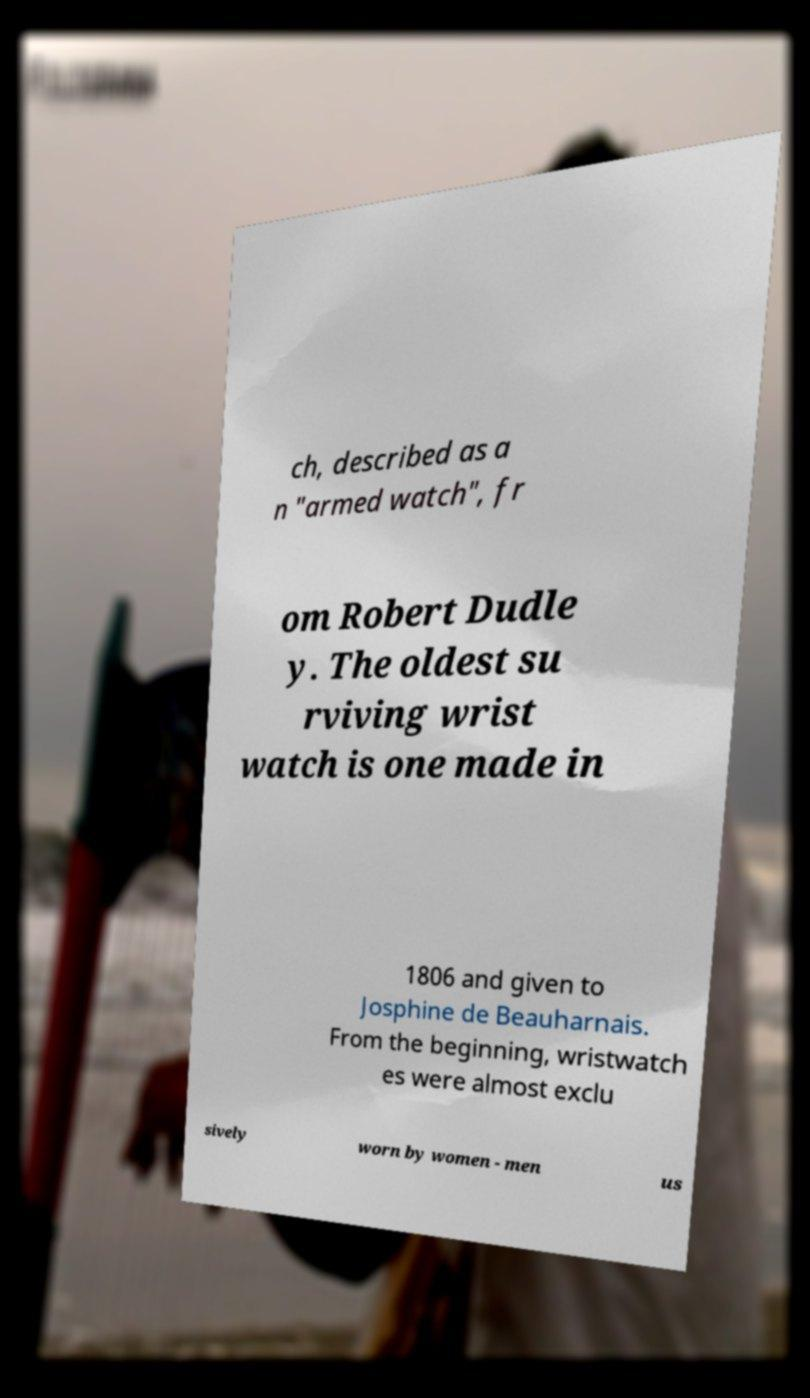There's text embedded in this image that I need extracted. Can you transcribe it verbatim? ch, described as a n "armed watch", fr om Robert Dudle y. The oldest su rviving wrist watch is one made in 1806 and given to Josphine de Beauharnais. From the beginning, wristwatch es were almost exclu sively worn by women - men us 